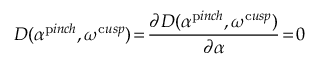Convert formula to latex. <formula><loc_0><loc_0><loc_500><loc_500>D ( \alpha ^ { p i n c h } , \omega ^ { c u s p } ) \, = \, \frac { \partial D ( \alpha ^ { p i n c h } , \omega ^ { c u s p } ) } { \partial \alpha } \, = \, 0</formula> 